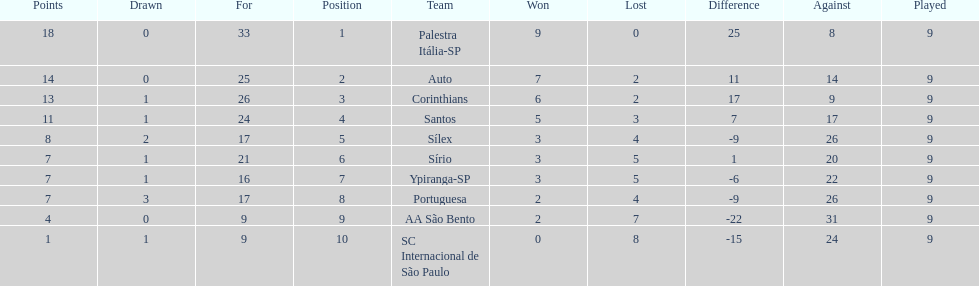Which brazilian team took the top spot in the 1926 brazilian football cup? Palestra Itália-SP. 